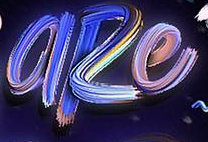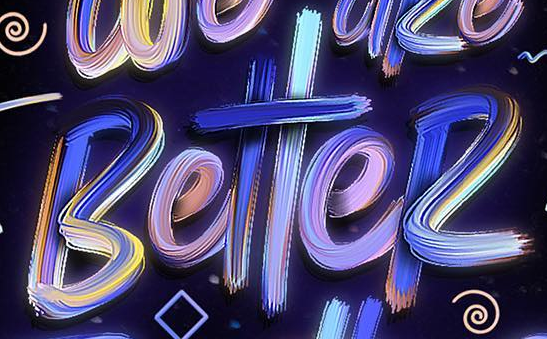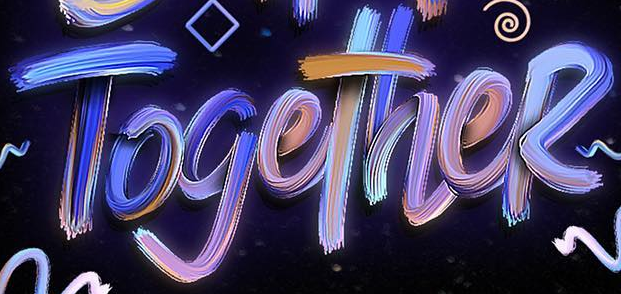Identify the words shown in these images in order, separated by a semicolon. aRe; BetteR; TogetheR 